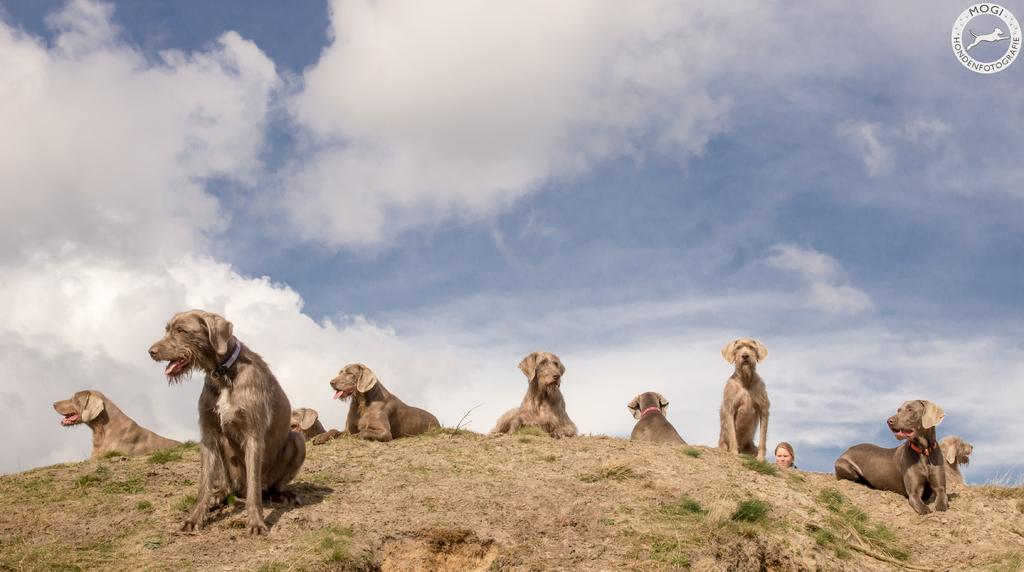What type of animals are in the image? There are dogs in the image. What are the dogs doing in the image? The dogs are standing and sitting on the grass. What can be seen in the background of the image? The background of the image includes the sky. What type of record can be seen spinning on a turntable in the image? There is no record or turntable present in the image; it features dogs standing and sitting on the grass with the sky in the background. 